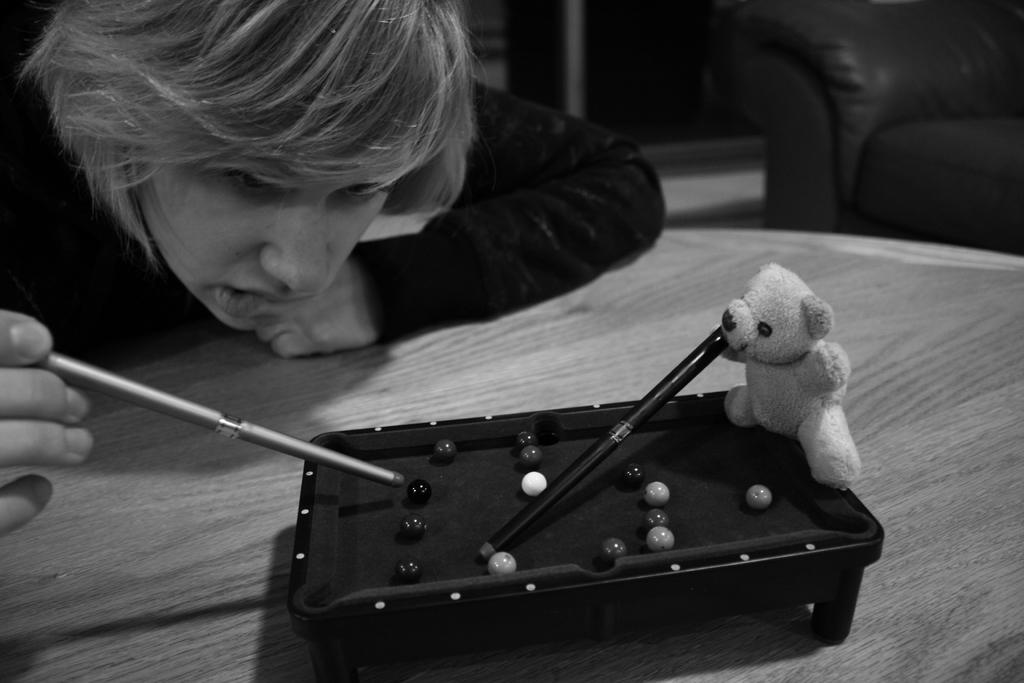Who or what is present in the image? There is a person in the image. What is the person holding in the image? The person is holding a stick. Can you describe the stick? The stick is a toy. What type of furniture is visible in the image? There is a sofa in the image. What type of art is being discussed by the person in the image? There is no indication in the image that the person is discussing any type of art. 